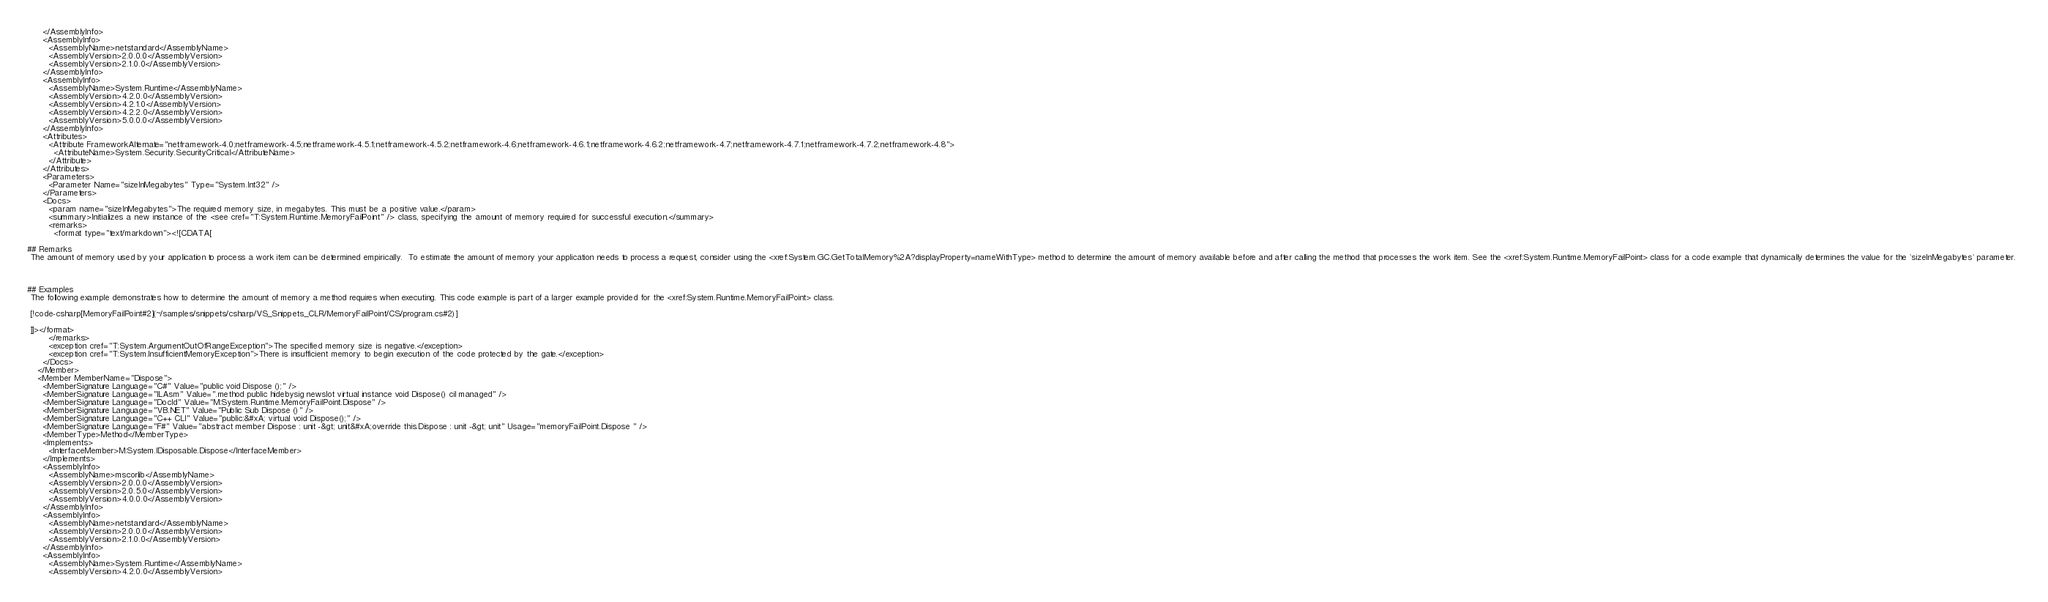Convert code to text. <code><loc_0><loc_0><loc_500><loc_500><_XML_>      </AssemblyInfo>
      <AssemblyInfo>
        <AssemblyName>netstandard</AssemblyName>
        <AssemblyVersion>2.0.0.0</AssemblyVersion>
        <AssemblyVersion>2.1.0.0</AssemblyVersion>
      </AssemblyInfo>
      <AssemblyInfo>
        <AssemblyName>System.Runtime</AssemblyName>
        <AssemblyVersion>4.2.0.0</AssemblyVersion>
        <AssemblyVersion>4.2.1.0</AssemblyVersion>
        <AssemblyVersion>4.2.2.0</AssemblyVersion>
        <AssemblyVersion>5.0.0.0</AssemblyVersion>
      </AssemblyInfo>
      <Attributes>
        <Attribute FrameworkAlternate="netframework-4.0;netframework-4.5;netframework-4.5.1;netframework-4.5.2;netframework-4.6;netframework-4.6.1;netframework-4.6.2;netframework-4.7;netframework-4.7.1;netframework-4.7.2;netframework-4.8">
          <AttributeName>System.Security.SecurityCritical</AttributeName>
        </Attribute>
      </Attributes>
      <Parameters>
        <Parameter Name="sizeInMegabytes" Type="System.Int32" />
      </Parameters>
      <Docs>
        <param name="sizeInMegabytes">The required memory size, in megabytes. This must be a positive value.</param>
        <summary>Initializes a new instance of the <see cref="T:System.Runtime.MemoryFailPoint" /> class, specifying the amount of memory required for successful execution.</summary>
        <remarks>
          <format type="text/markdown"><![CDATA[  
  
## Remarks  
 The amount of memory used by your application to process a work item can be determined empirically.  To estimate the amount of memory your application needs to process a request, consider using the <xref:System.GC.GetTotalMemory%2A?displayProperty=nameWithType> method to determine the amount of memory available before and after calling the method that processes the work item. See the <xref:System.Runtime.MemoryFailPoint> class for a code example that dynamically determines the value for the `sizeInMegabytes` parameter.  
  
   
  
## Examples  
 The following example demonstrates how to determine the amount of memory a method requires when executing. This code example is part of a larger example provided for the <xref:System.Runtime.MemoryFailPoint> class.  
  
 [!code-csharp[MemoryFailPoint#2](~/samples/snippets/csharp/VS_Snippets_CLR/MemoryFailPoint/CS/program.cs#2)]  
  
 ]]></format>
        </remarks>
        <exception cref="T:System.ArgumentOutOfRangeException">The specified memory size is negative.</exception>
        <exception cref="T:System.InsufficientMemoryException">There is insufficient memory to begin execution of the code protected by the gate.</exception>
      </Docs>
    </Member>
    <Member MemberName="Dispose">
      <MemberSignature Language="C#" Value="public void Dispose ();" />
      <MemberSignature Language="ILAsm" Value=".method public hidebysig newslot virtual instance void Dispose() cil managed" />
      <MemberSignature Language="DocId" Value="M:System.Runtime.MemoryFailPoint.Dispose" />
      <MemberSignature Language="VB.NET" Value="Public Sub Dispose ()" />
      <MemberSignature Language="C++ CLI" Value="public:&#xA; virtual void Dispose();" />
      <MemberSignature Language="F#" Value="abstract member Dispose : unit -&gt; unit&#xA;override this.Dispose : unit -&gt; unit" Usage="memoryFailPoint.Dispose " />
      <MemberType>Method</MemberType>
      <Implements>
        <InterfaceMember>M:System.IDisposable.Dispose</InterfaceMember>
      </Implements>
      <AssemblyInfo>
        <AssemblyName>mscorlib</AssemblyName>
        <AssemblyVersion>2.0.0.0</AssemblyVersion>
        <AssemblyVersion>2.0.5.0</AssemblyVersion>
        <AssemblyVersion>4.0.0.0</AssemblyVersion>
      </AssemblyInfo>
      <AssemblyInfo>
        <AssemblyName>netstandard</AssemblyName>
        <AssemblyVersion>2.0.0.0</AssemblyVersion>
        <AssemblyVersion>2.1.0.0</AssemblyVersion>
      </AssemblyInfo>
      <AssemblyInfo>
        <AssemblyName>System.Runtime</AssemblyName>
        <AssemblyVersion>4.2.0.0</AssemblyVersion></code> 